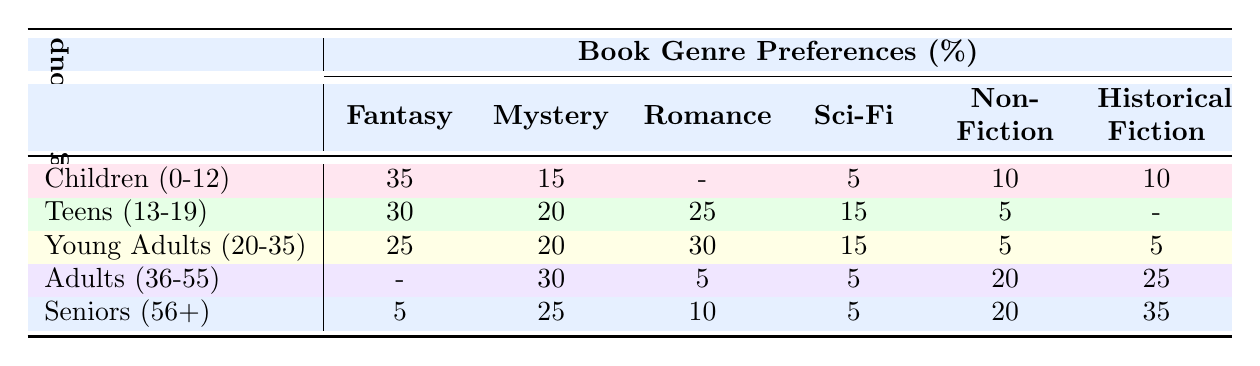What is the most preferred genre among Children (0-12)? According to the table, the most preferred genre for Children (0-12) is Fantasy, which has a preference value of 35.
Answer: Fantasy Which age group shows the highest preference for Mystery? By looking at the preference values for Mystery, the highest is found in Adults (36-55) with a value of 30.
Answer: Adults (36-55) What is the preference value for Historical Fiction among Seniors (56+)? The table shows that the preference value for Historical Fiction in the Seniors (56+) age group is 35.
Answer: 35 Is Romance a preferred genre for Adults (36-55)? The preference value for Romance in the Adults (36-55) age group is 5, indicating it is not a preferred genre. Thus, the answer is No.
Answer: No How does the preference for Sci-Fi compare between Teens (13-19) and Young Adults (20-35)? Teens (13-19) have a Sci-Fi preference value of 15 while Young Adults (20-35) have a value of 15 as well. Both age groups have the same preference for Sci-Fi.
Answer: Same (15) What is the total preference value for Fantasy among all age groups? The total preference for Fantasy can be calculated by adding the values for each age group: 35 (Children) + 30 (Teens) + 25 (Young Adults) + 5 (Adults) + 5 (Seniors) = 100.
Answer: 100 For which age group does Non-Fiction have the least preference? By examining the values in the table, Non-Fiction has its lowest preference in the Teens (13-19) age group, where the value is 5.
Answer: Teens (13-19) What is the average preference value for Historical Fiction across all age groups? The average can be calculated by summing the Historical Fiction values: 10 (Children) + 0 (Teens) + 5 (Young Adults) + 25 (Adults) + 35 (Seniors) = 75. There are 5 age groups, so the average is 75/5 = 15.
Answer: 15 Is there an age group that has a preference value of 0 for any genre? Upon reviewing the table, we see that there is a value of 0 for Romance in the Children (0-12) age group and for the Teens (13-19) age group in Historical Fiction. Thus, the answer is Yes.
Answer: Yes 